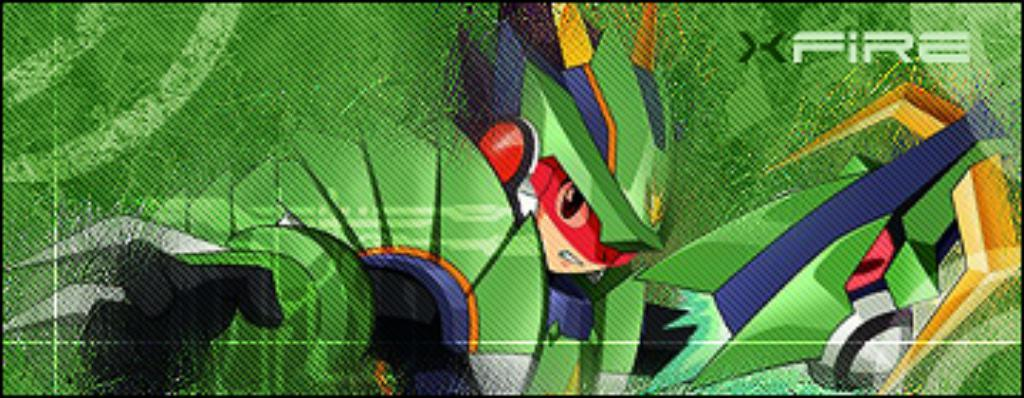What color is the poster in the image? The poster in the image is green. What is depicted on the poster? The poster features a person. Is there any text on the poster? No specific mention of text is given, but there is a name in the top right corner of the image. What type of iron can be seen in the image? There is no iron present in the image. How does the person on the poster feel about the summer season? The image does not provide any information about the person's feelings or the summer season. 